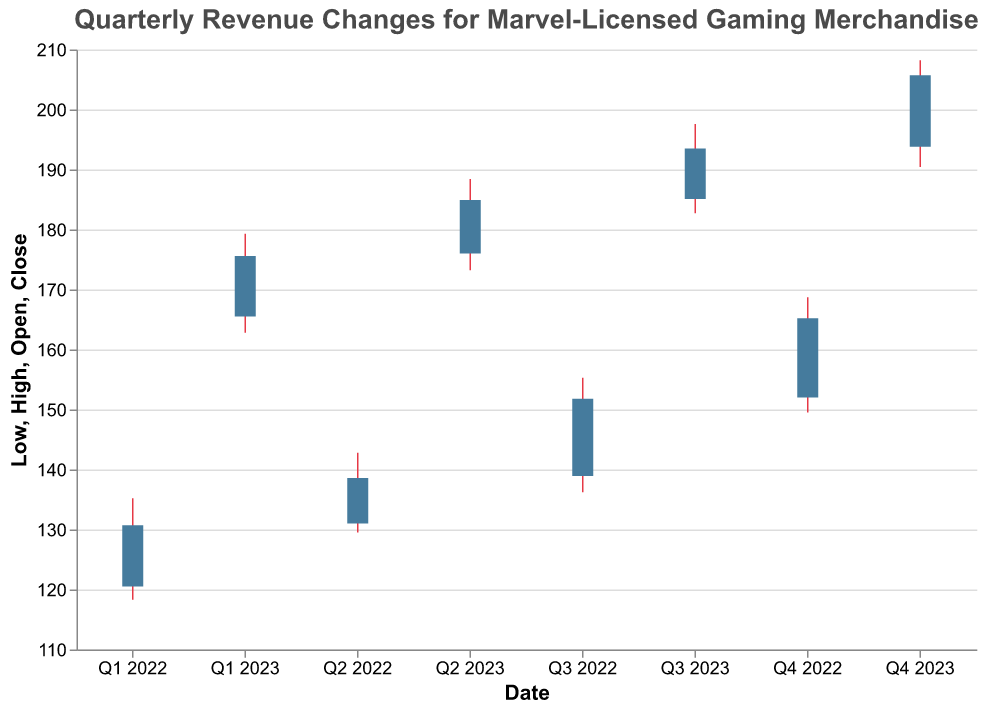what is the title of the figure? The title of the figure is "Quarterly Revenue Changes for Marvel-Licensed Gaming Merchandise", which is displayed prominently at the top of the chart.
Answer: Quarterly Revenue Changes for Marvel-Licensed Gaming Merchandise How many data points are there in the chart? The chart displays one data point for each quarter from Q1 2022 to Q4 2023, which amounts to 8 data points.
Answer: 8 Which quarter had the highest revenue closing value? To find the highest revenue closing value, look at the "Close" values for each quarter. Q4 2023 has the highest close value of 205.7.
Answer: Q4 2023 During which quarter did the revenue opening value increase the most compared to the previous quarter? Calculate the difference in opening values between consecutive quarters. The biggest increase is between Q4 2022 (152.0) to Q1 2023 (165.5), which is an increase of 13.5.
Answer: Q1 2023 What is the range of revenue values for Q2 2023? The range is the difference between the high and low values. For Q2 2023, the high is 188.4 and the low is 173.2, so the range is 188.4 - 173.2 = 15.2.
Answer: 15.2 Which quarter showed the smallest difference between its high and low values? The difference between high and low values for each quarter is smallest for Q1 2022, which has a high of 135.2 and a low of 118.3, resulting in a difference of 16.9.
Answer: Q1 2022 How much did the opening revenue increase from Q1 2022 to Q4 2023? The opening revenue in Q1 2022 was 120.5, and in Q4 2023 it was 193.8. Therefore, the increase is 193.8 - 120.5 = 73.3.
Answer: 73.3 Compare the highest high values for 2022 and 2023. Which year had the higher peak? The highest high value for 2022 is 168.7, while for 2023 it is 208.2. Therefore, 2023 had the higher peak.
Answer: 2023 What is the average closing value for 2022? The closing values for 2022 are 130.7, 138.6, 151.8, and 165.2. The average is (130.7 + 138.6 + 151.8 + 165.2) / 4 = 146.575.
Answer: 146.575 Is there any quarter where the closing value is lower than the opening value? To check for this, compare the open and close values for each quarter. No quarter has a closing value lower than its opening value.
Answer: No 